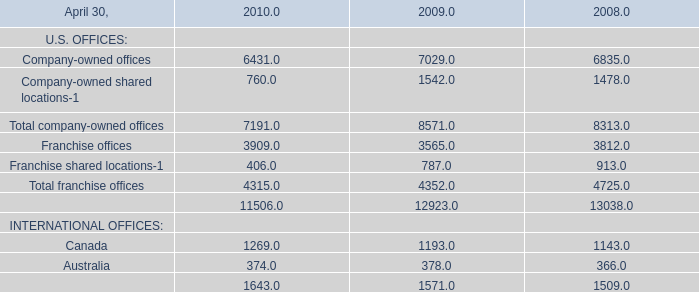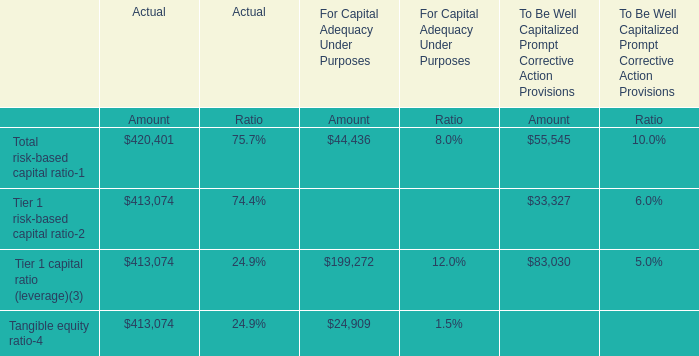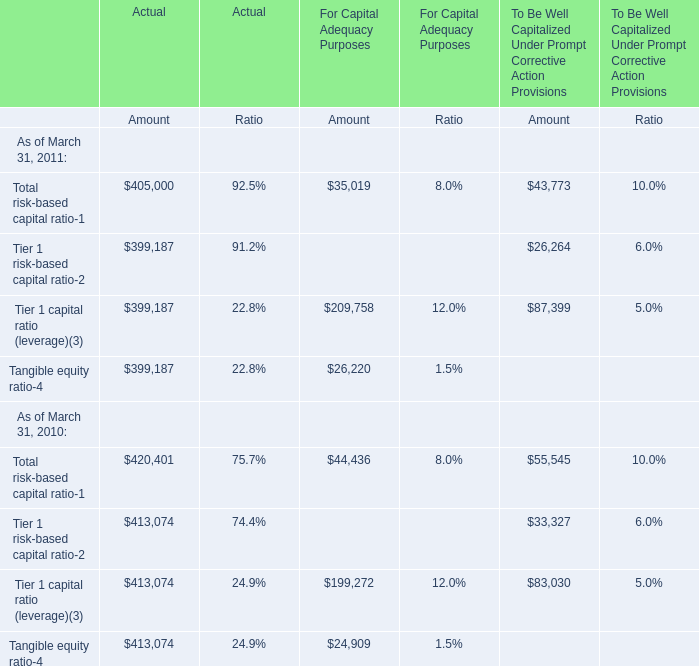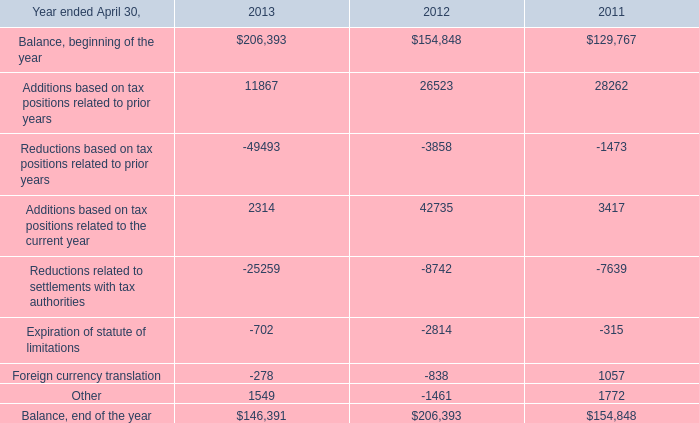What is the sum of Canada in 2008 and Other in 2011? 
Computations: (1143 + 1772)
Answer: 2915.0. 